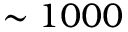Convert formula to latex. <formula><loc_0><loc_0><loc_500><loc_500>\sim 1 0 0 0</formula> 